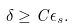Convert formula to latex. <formula><loc_0><loc_0><loc_500><loc_500>\delta \geq C \epsilon _ { s } .</formula> 